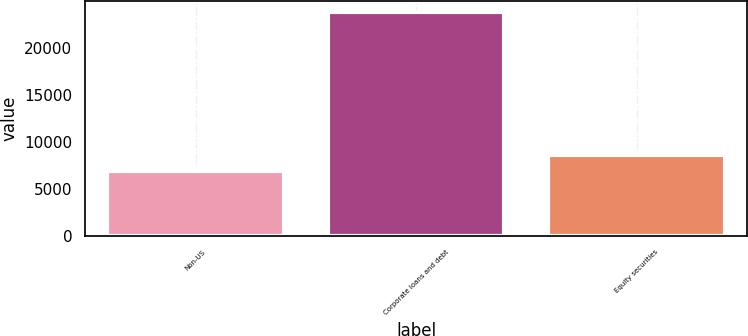Convert chart to OTSL. <chart><loc_0><loc_0><loc_500><loc_500><bar_chart><fcel>Non-US<fcel>Corporate loans and debt<fcel>Equity securities<nl><fcel>6933<fcel>23804<fcel>8620.1<nl></chart> 